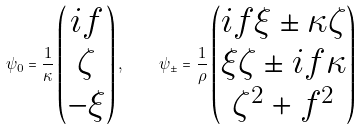Convert formula to latex. <formula><loc_0><loc_0><loc_500><loc_500>\psi _ { 0 } = \frac { 1 } { \kappa } \left ( \begin{matrix} i f \\ \zeta \\ - \xi \end{matrix} \right ) , \quad \psi _ { \pm } = \frac { 1 } \rho \left ( \begin{matrix} i f \xi \pm \kappa \zeta \\ \xi \zeta \pm i f \kappa \\ \zeta ^ { 2 } + f ^ { 2 } \end{matrix} \right )</formula> 